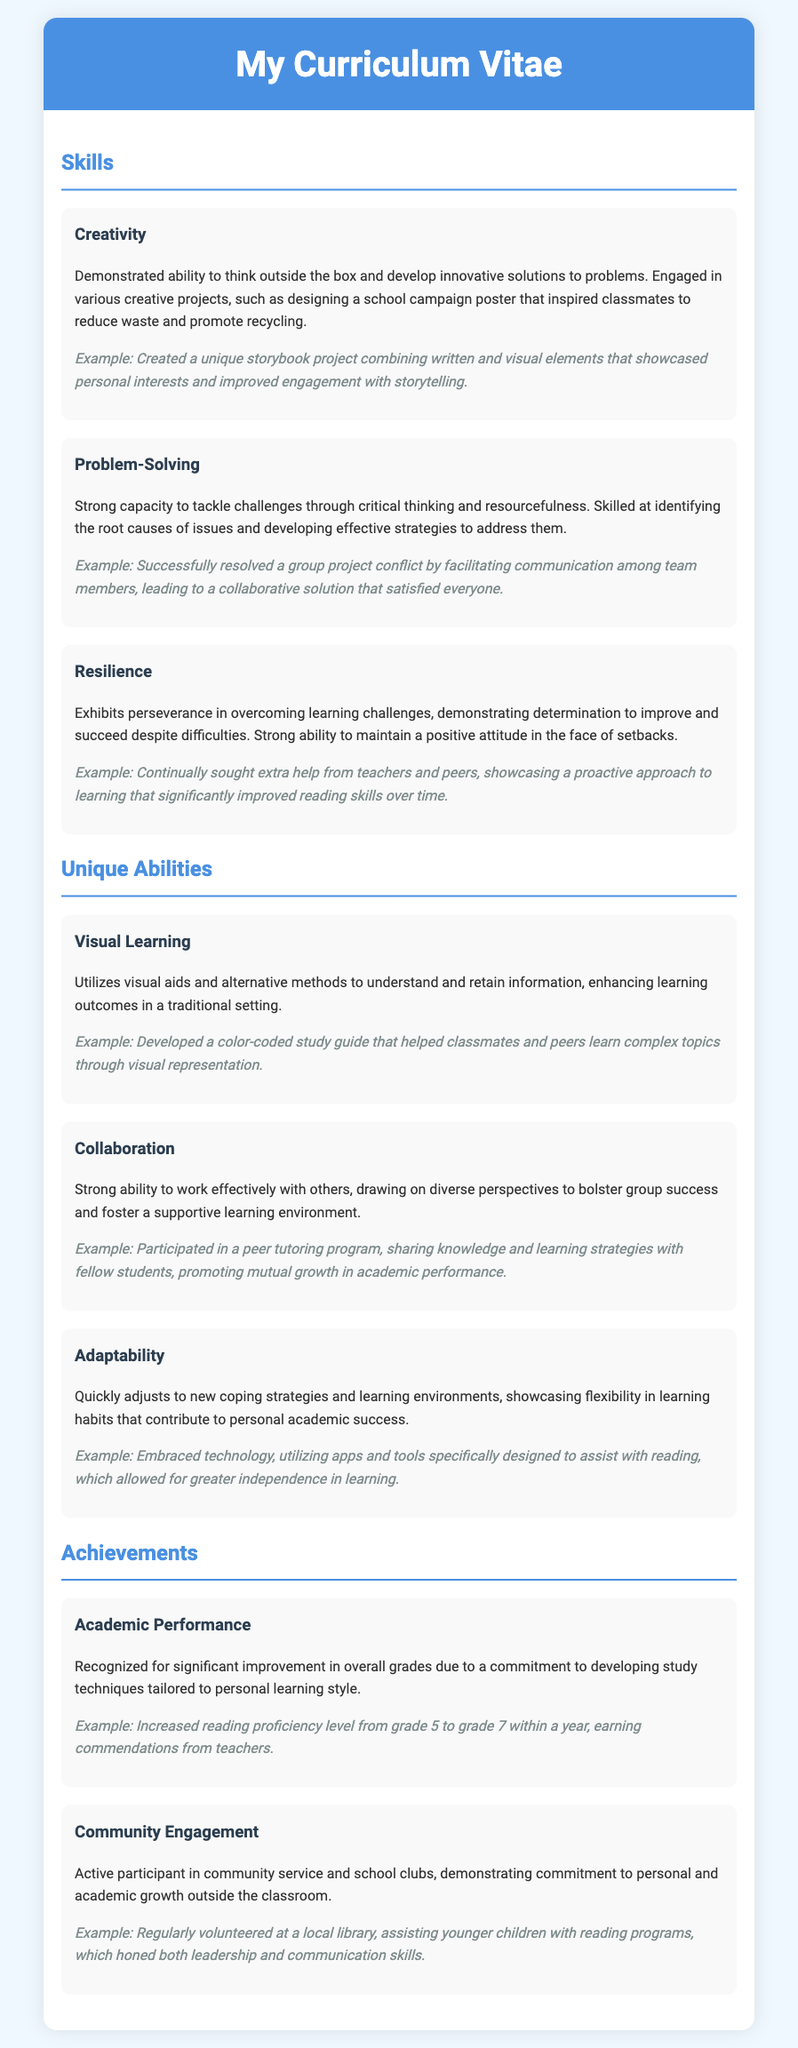what is one skill mentioned in the document? The document lists several skills, one of which is creativity.
Answer: creativity provide an example of a problem-solving achievement. The document states that the individual successfully resolved a group project conflict.
Answer: resolving a group project conflict what ability is highlighted alongside collaboration? The document highlights adaptability as another ability.
Answer: adaptability how did the individual demonstrate resilience? The document mentions that the individual continually sought extra help from teachers and peers.
Answer: sought extra help from teachers and peers what was the change in reading proficiency level? The document indicates that the individual's reading proficiency level increased from grade 5 to grade 7.
Answer: grade 5 to grade 7 which color-coded tool helped classmates? The document describes a color-coded study guide as a visual aid developed by the individual.
Answer: color-coded study guide what is a unique ability mentioned in the CV? The document mentions visual learning as a unique ability.
Answer: visual learning what community engagement activity did the individual participate in? The individual regularly volunteered at a local library according to the document.
Answer: volunteered at a local library what is the overall theme of the curriculum vitae? The overall theme focuses on skills and strengths contributing to academic success.
Answer: skills and strengths contributing to academic success 